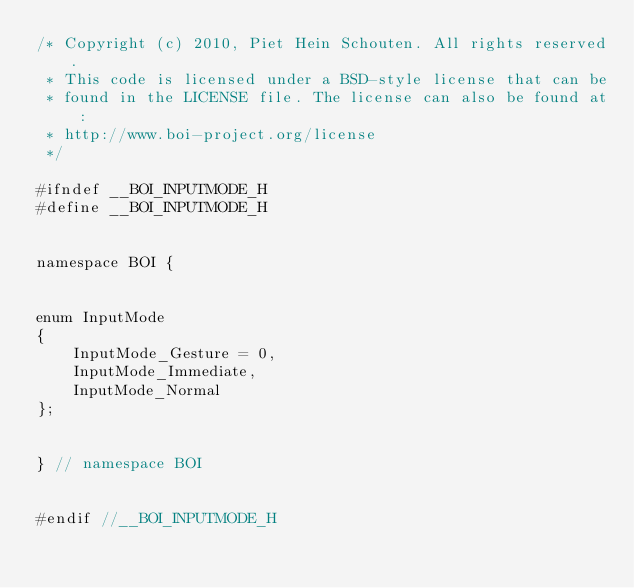<code> <loc_0><loc_0><loc_500><loc_500><_C_>/* Copyright (c) 2010, Piet Hein Schouten. All rights reserved.
 * This code is licensed under a BSD-style license that can be
 * found in the LICENSE file. The license can also be found at:
 * http://www.boi-project.org/license
 */

#ifndef __BOI_INPUTMODE_H
#define __BOI_INPUTMODE_H


namespace BOI {


enum InputMode
{
    InputMode_Gesture = 0,
    InputMode_Immediate,
    InputMode_Normal
};


} // namespace BOI


#endif //__BOI_INPUTMODE_H

</code> 